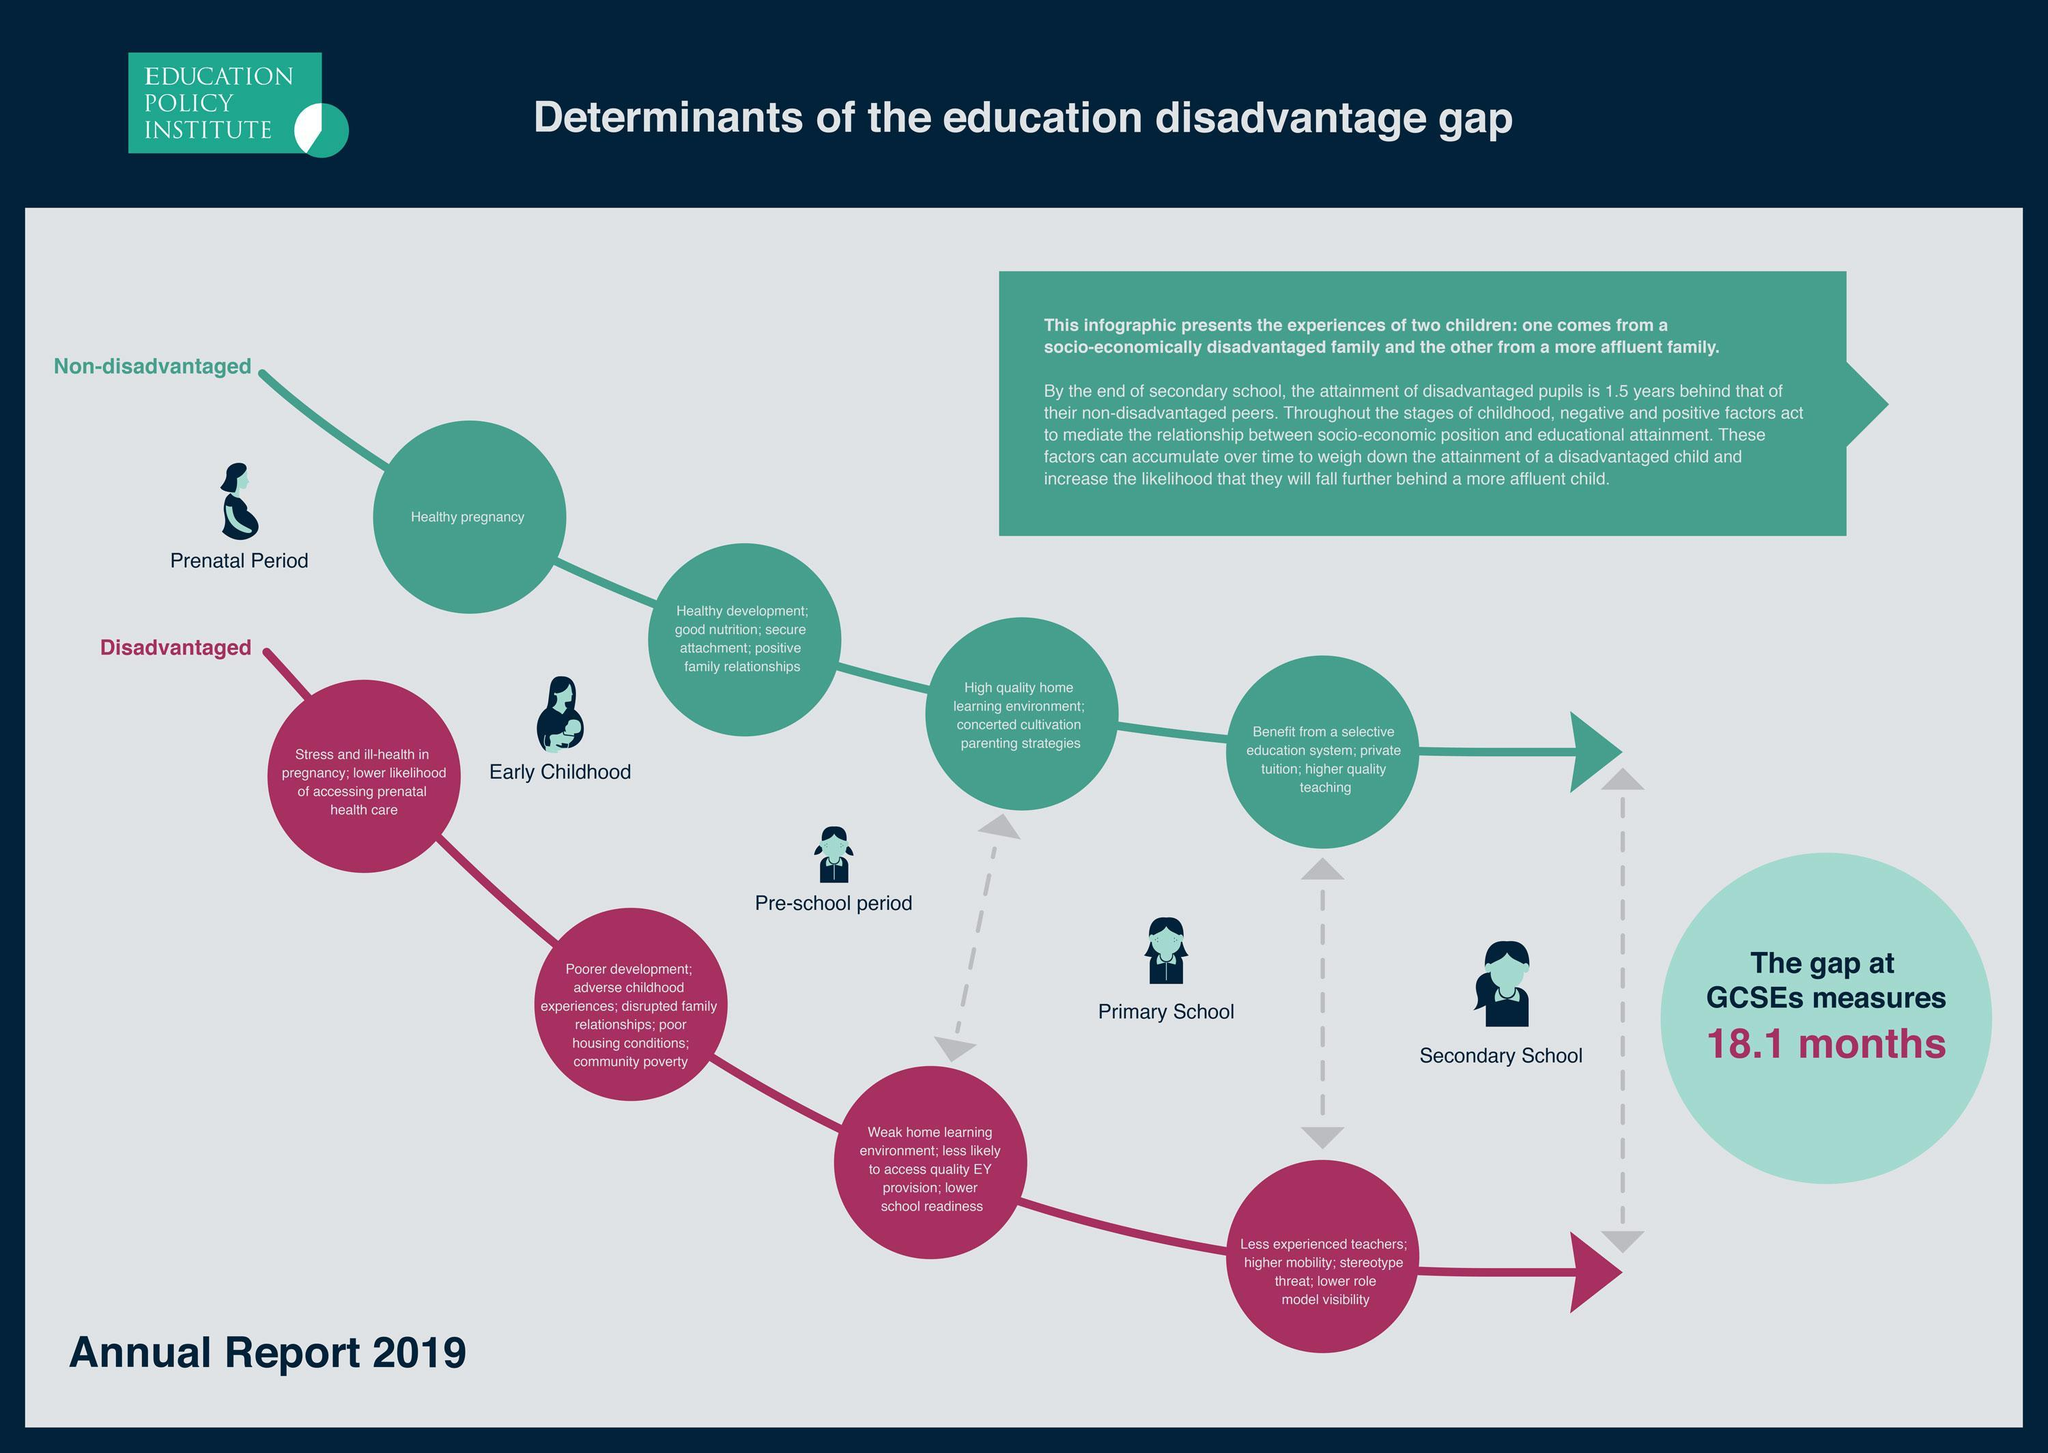Which child's mother might have faced stress and ill-health during pregnancy?
Answer the question with a short phrase. disadvantaged What type of relationships exist in non-disadvantaged family background? positive family relationships Which child gets lower role model visibility? disadvantaged Which child gets access to private tuition or higher quality teaching? non-disadvantaged Which child's mother is more likely to have had a healthy pregnancy? non-disadvantaged Which child gets less experienced teachers in primary school? disadvantaged What type of relationships exist in disadvantaged family? disrupted family relationships Which child had good nutrition in early childhood? non-disadvantaged What type of environment does a non-disadvantaged child have during pre-school period? high quality learning environment What type of environment does a disadvantaged child have during pre-school period? Weak home learning environment 